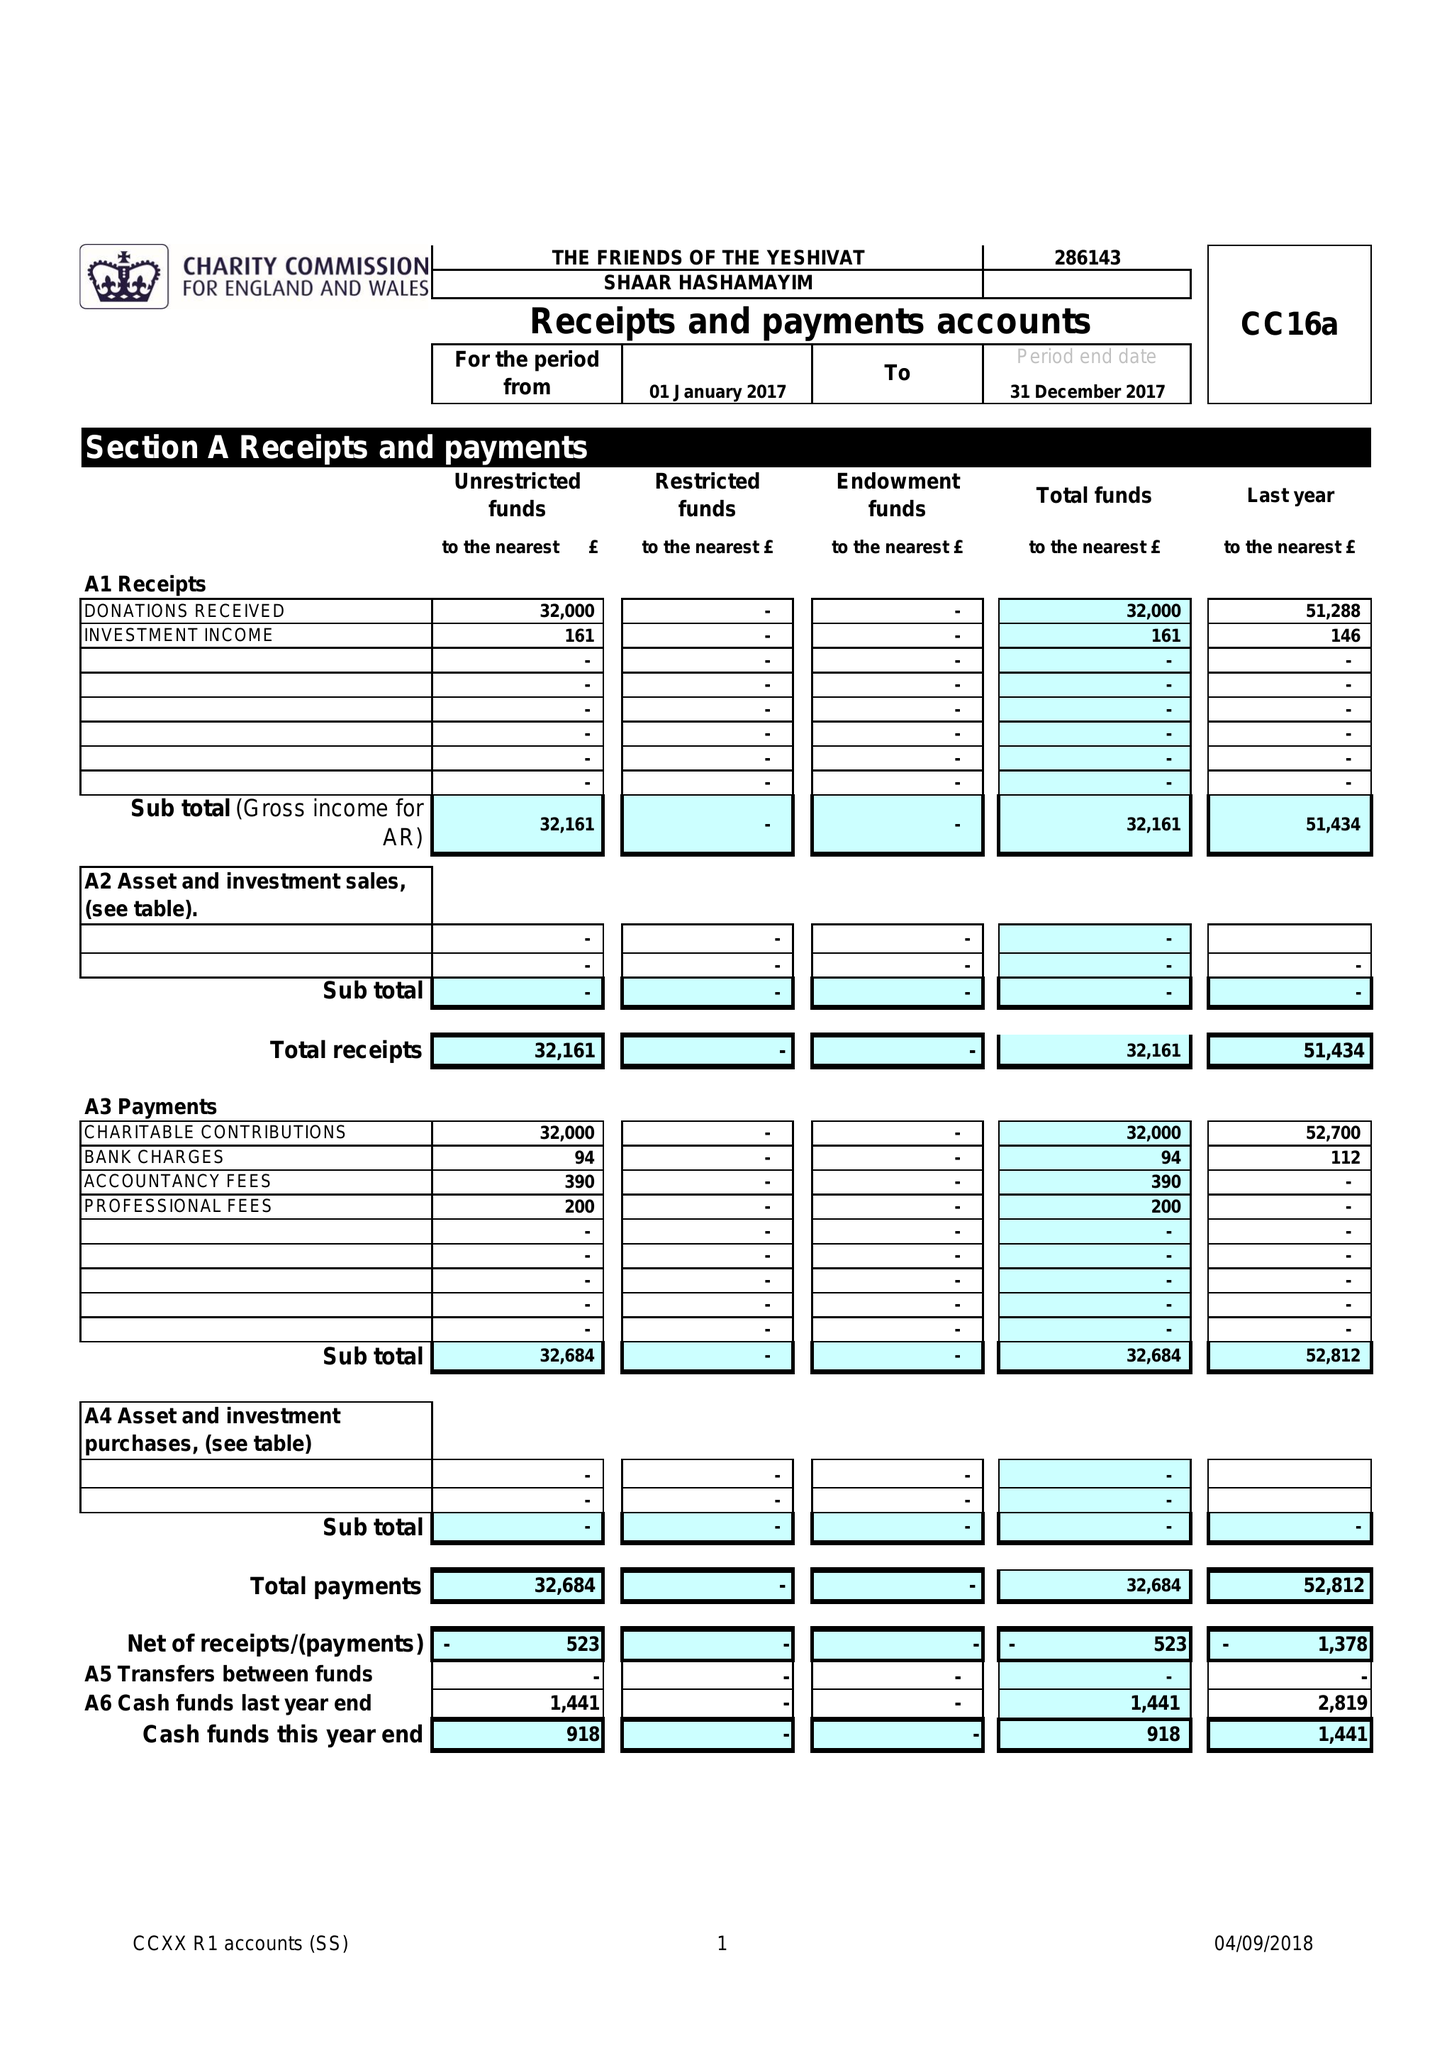What is the value for the income_annually_in_british_pounds?
Answer the question using a single word or phrase. 32161.00 